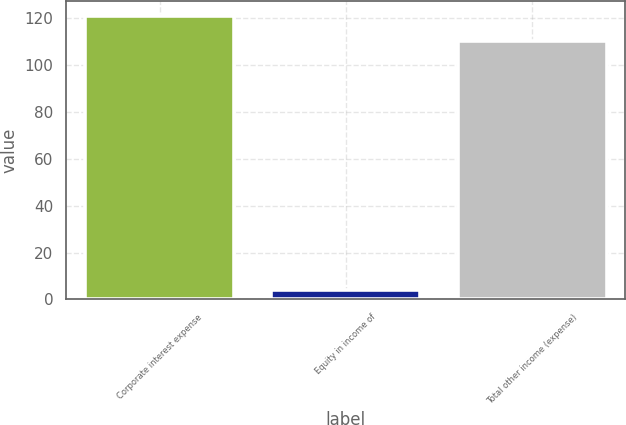<chart> <loc_0><loc_0><loc_500><loc_500><bar_chart><fcel>Corporate interest expense<fcel>Equity in income of<fcel>Total other income (expense)<nl><fcel>121<fcel>4<fcel>110<nl></chart> 